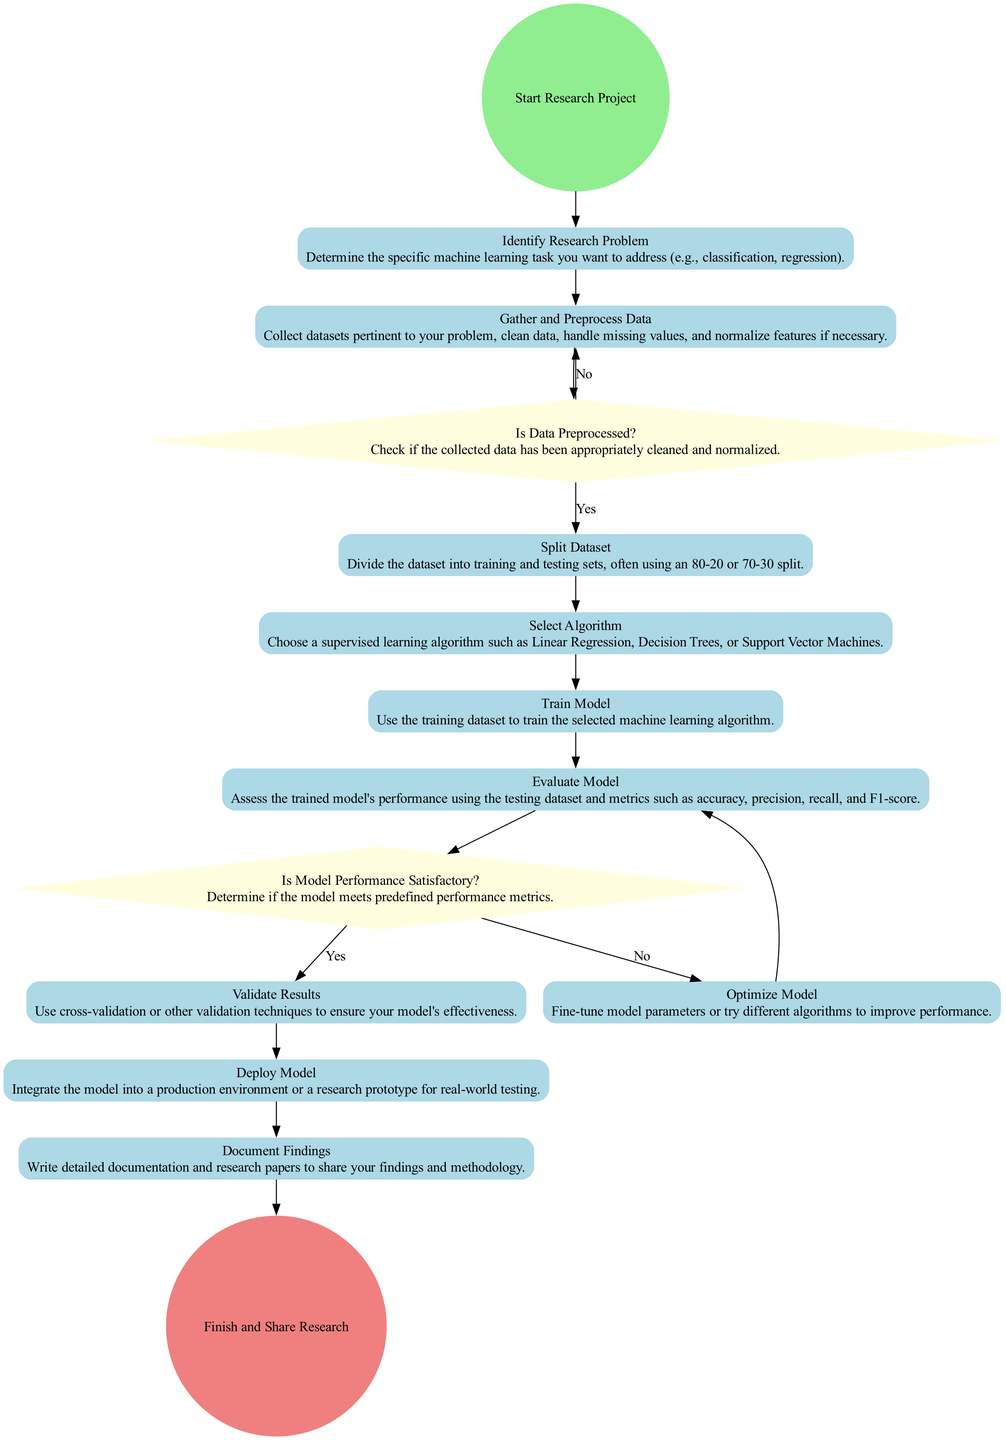What is the starting point of the diagram? The starting point is indicated by the "Start Research Project" node, which is where the activity sequence begins in the diagram.
Answer: Start Research Project How many activities are present in the diagram? By counting the individual nodes labeled as activities, we can see that there are ten activities listed in the diagram.
Answer: 10 What decision comes after the "Gather and Preprocess Data" activity? The decision following the "Gather and Preprocess Data" activity is "Is Data Preprocessed?" which checks if the data is clean and normalized.
Answer: Is Data Preprocessed? What happens if the model performance is not satisfactory? If the model performance is not satisfactory, the diagram shows that the flow returns to the "Train Model" activity to re-train and optimize the model parameters.
Answer: Train Model Which activity follows after "Deploy Model"? The activity that comes after "Deploy Model" is "Document Findings," which signifies the end of the algorithm implementation process with documentation.
Answer: Document Findings What is the last event in the diagram? The last event is the "Finish and Share Research" which indicates the conclusion of the research project and sharing of findings.
Answer: Finish and Share Research What is the relationship between "Evaluate Model" and "Optimize Model"? The "Evaluate Model" activity leads to the "Is Model Performance Satisfactory?" decision, and based on that decision, it may move on to "Optimize Model" if the performance is deemed unsatisfactory.
Answer: Evaluate Model leads to Optimize Model What is checked before splitting the dataset? Before splitting the dataset, the diagram checks whether the data has been preprocessed by asking "Is Data Preprocessed?".
Answer: Is Data Preprocessed? What does the algorithm selection depend on? The selection of the algorithm is influenced by the identified research problem, determining the best-suited supervised learning algorithm for the task.
Answer: Identified research problem 